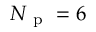<formula> <loc_0><loc_0><loc_500><loc_500>N _ { p } = 6</formula> 